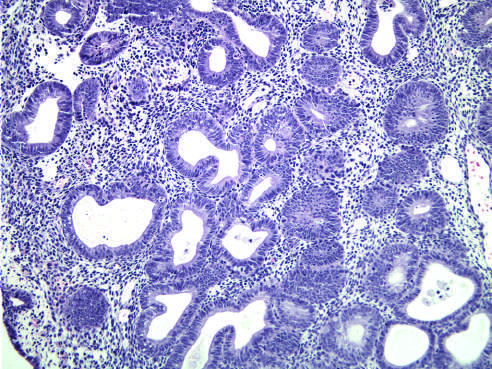s hyperplasia without atypia characterized by nests of closely packed glands?
Answer the question using a single word or phrase. Yes 